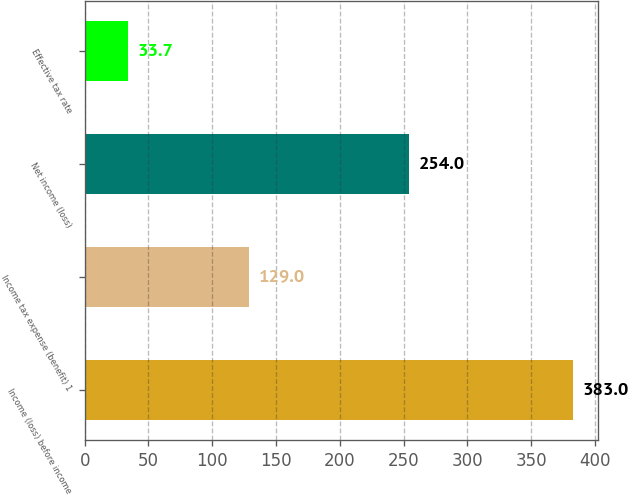Convert chart to OTSL. <chart><loc_0><loc_0><loc_500><loc_500><bar_chart><fcel>Income (loss) before income<fcel>Income tax expense (benefit) 1<fcel>Net income (loss)<fcel>Effective tax rate<nl><fcel>383<fcel>129<fcel>254<fcel>33.7<nl></chart> 